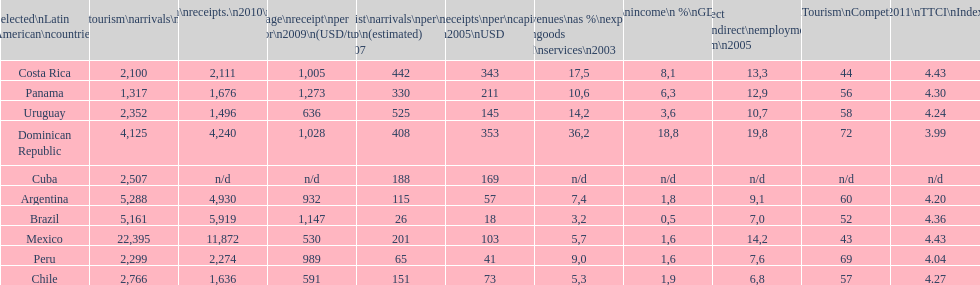What is the name of the country that had the most international tourism arrivals in 2010? Mexico. 